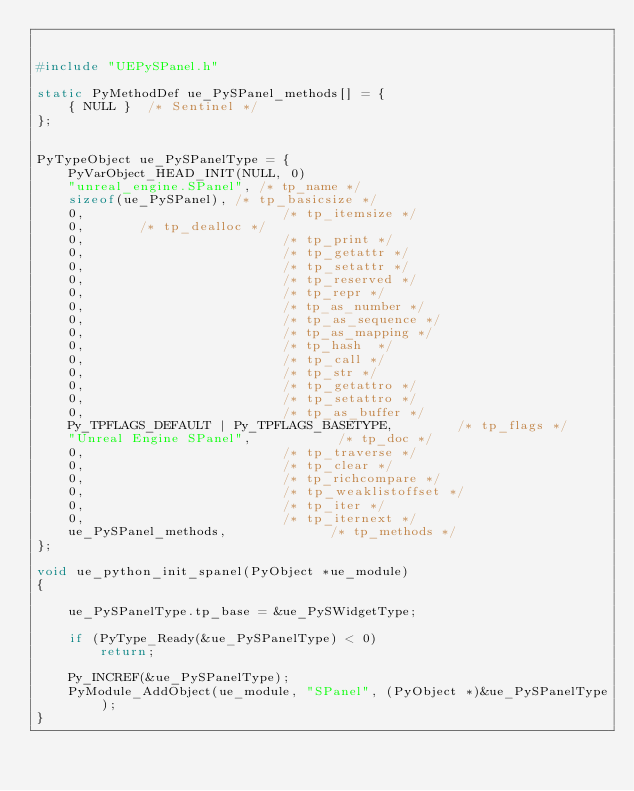Convert code to text. <code><loc_0><loc_0><loc_500><loc_500><_C++_>

#include "UEPySPanel.h"

static PyMethodDef ue_PySPanel_methods[] = {
	{ NULL }  /* Sentinel */
};


PyTypeObject ue_PySPanelType = {
	PyVarObject_HEAD_INIT(NULL, 0)
	"unreal_engine.SPanel", /* tp_name */
	sizeof(ue_PySPanel), /* tp_basicsize */
	0,                         /* tp_itemsize */
	0,       /* tp_dealloc */
	0,                         /* tp_print */
	0,                         /* tp_getattr */
	0,                         /* tp_setattr */
	0,                         /* tp_reserved */
	0,                         /* tp_repr */
	0,                         /* tp_as_number */
	0,                         /* tp_as_sequence */
	0,                         /* tp_as_mapping */
	0,                         /* tp_hash  */
	0,                         /* tp_call */
	0,                         /* tp_str */
	0,                         /* tp_getattro */
	0,                         /* tp_setattro */
	0,                         /* tp_as_buffer */
	Py_TPFLAGS_DEFAULT | Py_TPFLAGS_BASETYPE,        /* tp_flags */
	"Unreal Engine SPanel",           /* tp_doc */
	0,                         /* tp_traverse */
	0,                         /* tp_clear */
	0,                         /* tp_richcompare */
	0,                         /* tp_weaklistoffset */
	0,                         /* tp_iter */
	0,                         /* tp_iternext */
	ue_PySPanel_methods,             /* tp_methods */
};

void ue_python_init_spanel(PyObject *ue_module)
{

	ue_PySPanelType.tp_base = &ue_PySWidgetType;

	if (PyType_Ready(&ue_PySPanelType) < 0)
		return;

	Py_INCREF(&ue_PySPanelType);
	PyModule_AddObject(ue_module, "SPanel", (PyObject *)&ue_PySPanelType);
}
</code> 